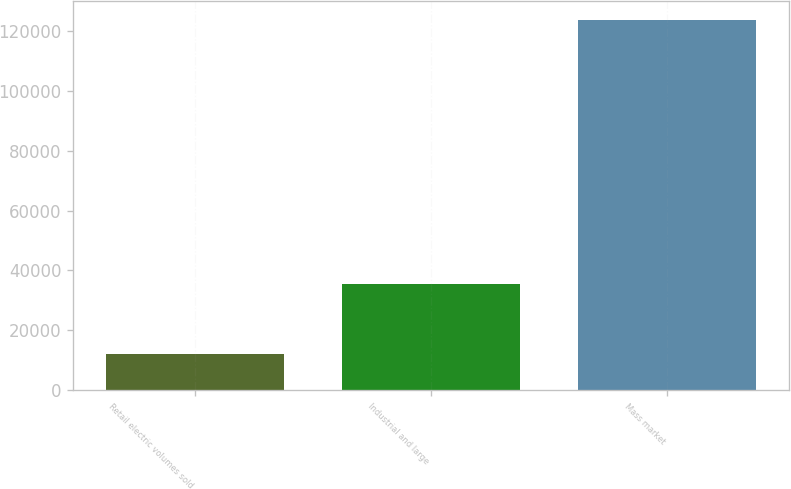Convert chart to OTSL. <chart><loc_0><loc_0><loc_500><loc_500><bar_chart><fcel>Retail electric volumes sold<fcel>Industrial and large<fcel>Mass market<nl><fcel>12167<fcel>35504<fcel>123813<nl></chart> 